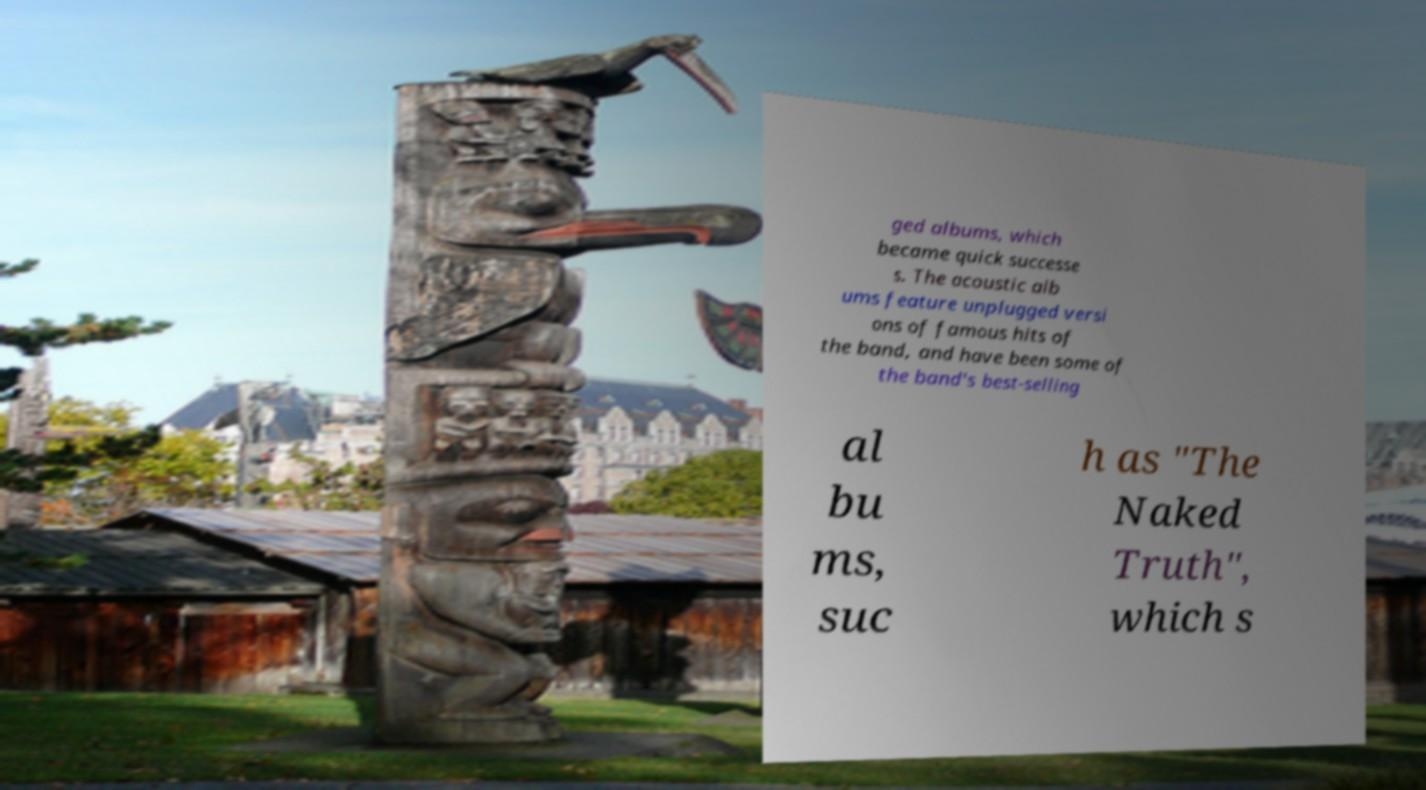There's text embedded in this image that I need extracted. Can you transcribe it verbatim? ged albums, which became quick successe s. The acoustic alb ums feature unplugged versi ons of famous hits of the band, and have been some of the band's best-selling al bu ms, suc h as "The Naked Truth", which s 